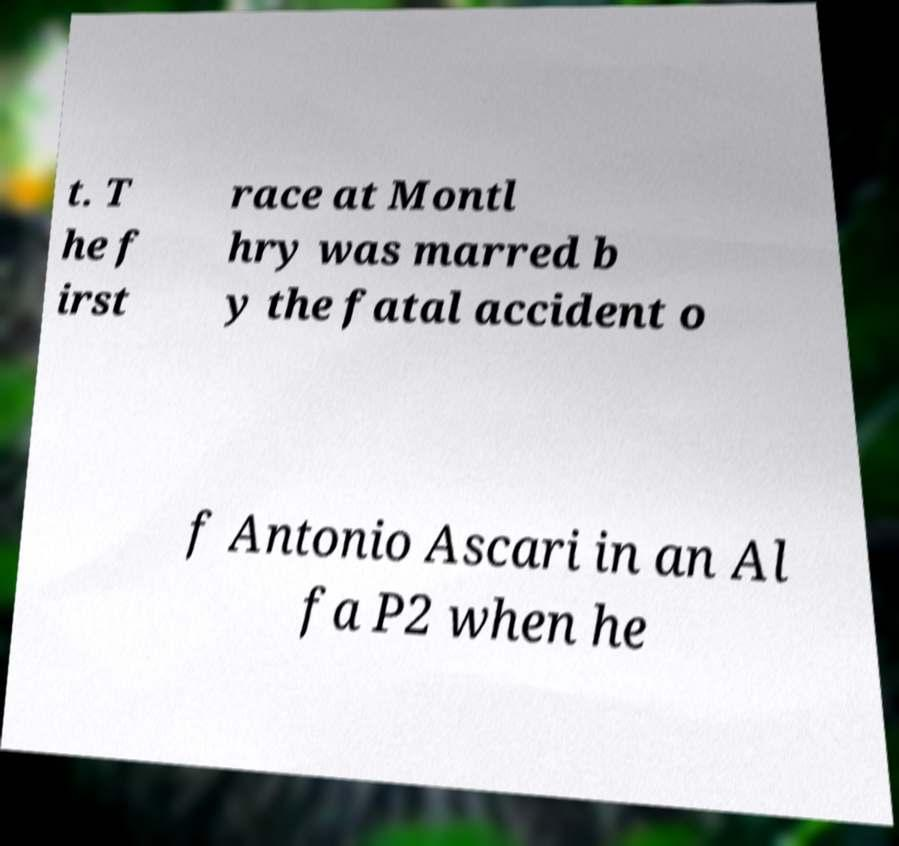For documentation purposes, I need the text within this image transcribed. Could you provide that? t. T he f irst race at Montl hry was marred b y the fatal accident o f Antonio Ascari in an Al fa P2 when he 